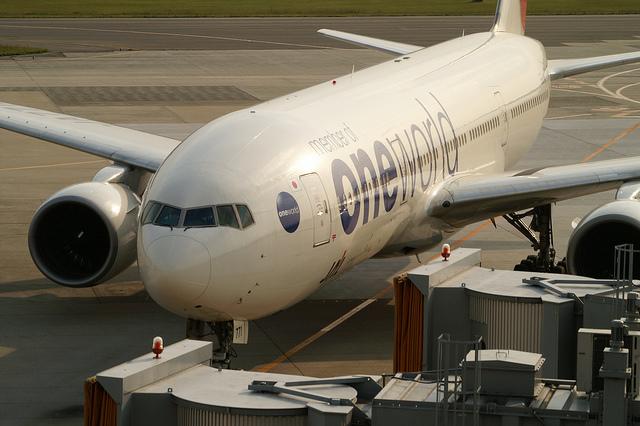What alliance is this plane part of?
Give a very brief answer. One world. Are there other vehicles on the tarmac?
Be succinct. No. What is the name of the airline?
Give a very brief answer. One world. What color is the plane?
Keep it brief. White. What type of aircraft is this?
Write a very short answer. Passenger jet. 